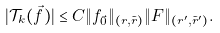<formula> <loc_0><loc_0><loc_500><loc_500>| \mathcal { T } _ { k } ( \vec { f } ) | \leq C \| f _ { \vec { 0 } } \| _ { ( r , \tilde { r } ) } \| F \| _ { ( r ^ { \prime } , \tilde { r } ^ { \prime } ) } .</formula> 